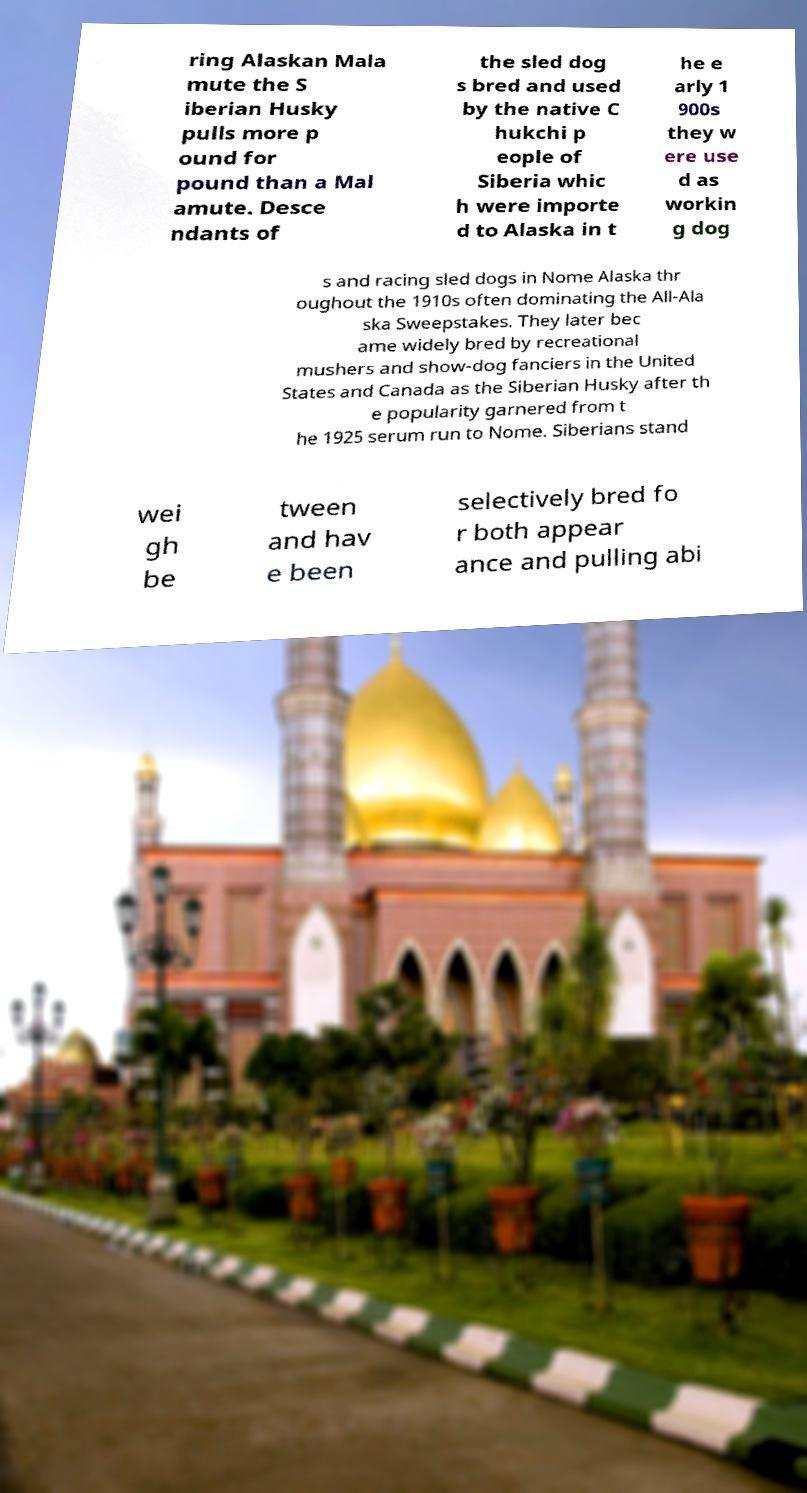Can you read and provide the text displayed in the image?This photo seems to have some interesting text. Can you extract and type it out for me? ring Alaskan Mala mute the S iberian Husky pulls more p ound for pound than a Mal amute. Desce ndants of the sled dog s bred and used by the native C hukchi p eople of Siberia whic h were importe d to Alaska in t he e arly 1 900s they w ere use d as workin g dog s and racing sled dogs in Nome Alaska thr oughout the 1910s often dominating the All-Ala ska Sweepstakes. They later bec ame widely bred by recreational mushers and show-dog fanciers in the United States and Canada as the Siberian Husky after th e popularity garnered from t he 1925 serum run to Nome. Siberians stand wei gh be tween and hav e been selectively bred fo r both appear ance and pulling abi 